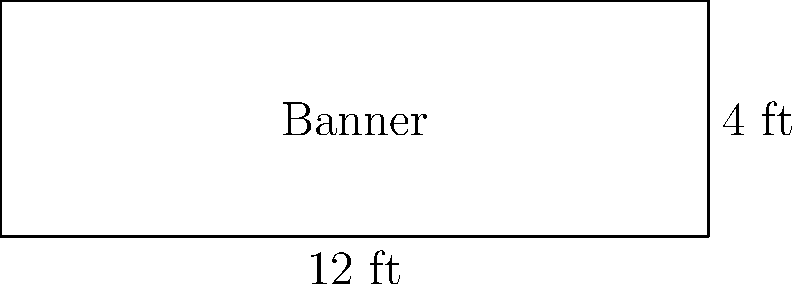For a social equality rally, you're designing a rectangular banner. The banner is 12 feet wide and has an area of 48 square feet. What is the height of the banner? Let's approach this step-by-step:

1) We know that the banner is rectangular, so we can use the area formula for a rectangle:
   $$ \text{Area} = \text{Width} \times \text{Height} $$

2) We're given that:
   - The width is 12 feet
   - The area is 48 square feet

3) Let's substitute these values into our formula:
   $$ 48 = 12 \times \text{Height} $$

4) Now we can solve for the height:
   $$ \text{Height} = \frac{48}{12} = 4 $$

5) Therefore, the height of the banner is 4 feet.

This size is practical for a rally banner, as it's large enough to be visible but not so large as to be unwieldy for volunteers to handle.
Answer: 4 feet 